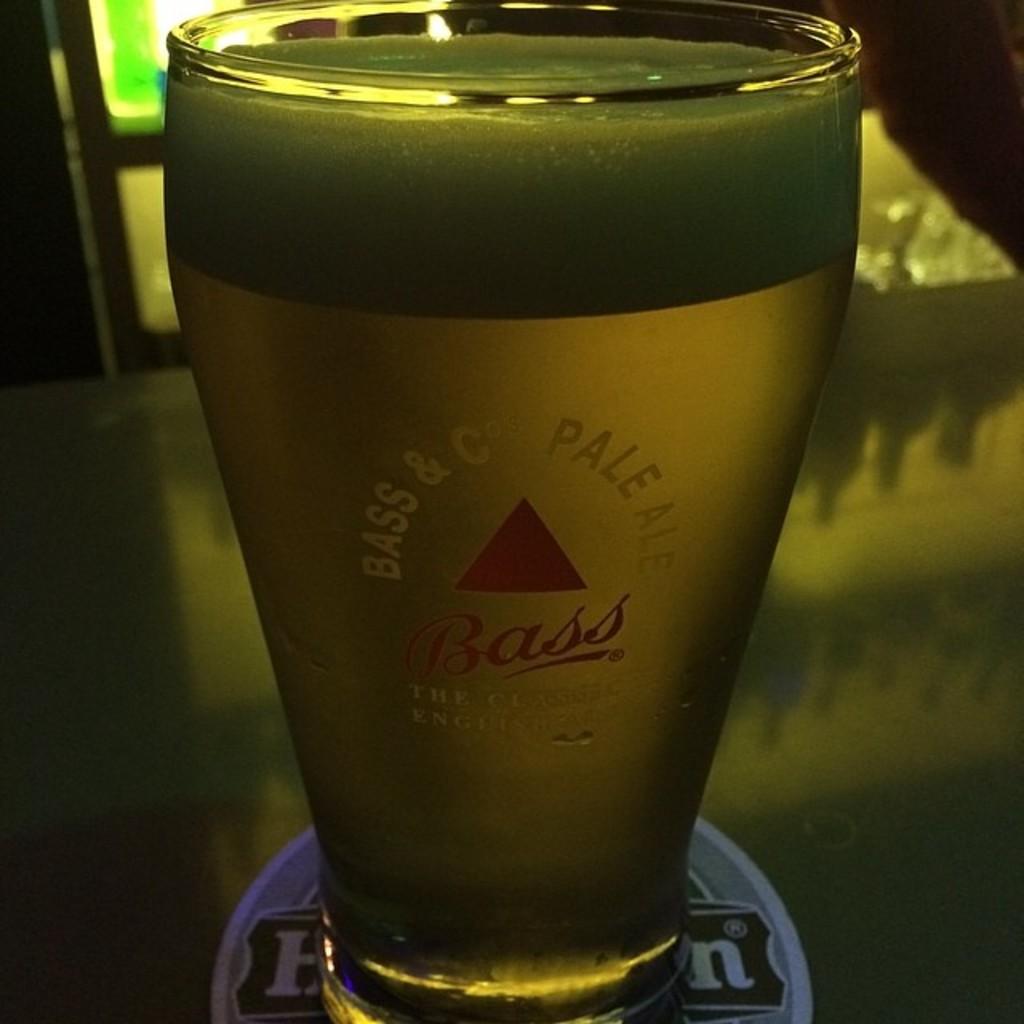What brand of pale ale is this?
Provide a succinct answer. Bass. What is the brand of this ale?
Give a very brief answer. Bass. 